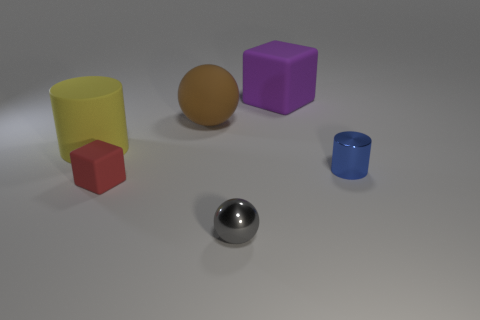Add 2 blue metallic things. How many objects exist? 8 Subtract all cubes. How many objects are left? 4 Subtract 0 gray blocks. How many objects are left? 6 Subtract all gray blocks. Subtract all yellow objects. How many objects are left? 5 Add 5 cubes. How many cubes are left? 7 Add 2 tiny red matte objects. How many tiny red matte objects exist? 3 